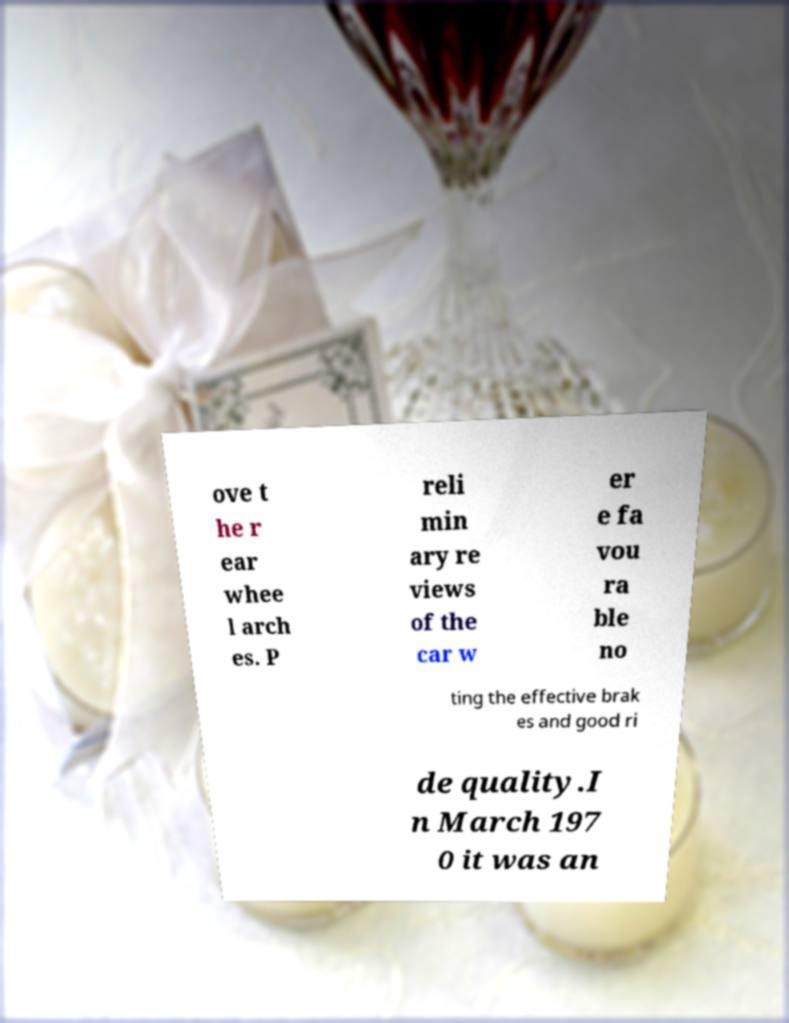Can you accurately transcribe the text from the provided image for me? ove t he r ear whee l arch es. P reli min ary re views of the car w er e fa vou ra ble no ting the effective brak es and good ri de quality.I n March 197 0 it was an 